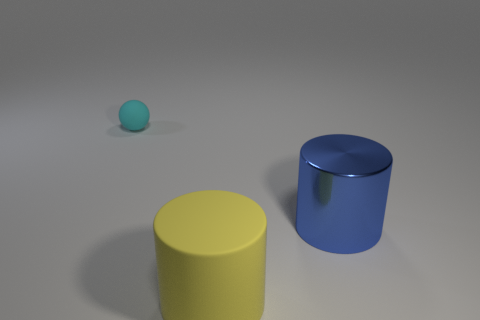Add 2 rubber things. How many objects exist? 5 Subtract 1 cylinders. How many cylinders are left? 1 Subtract all spheres. How many objects are left? 2 Add 2 cyan matte things. How many cyan matte things are left? 3 Add 3 big blue things. How many big blue things exist? 4 Subtract 0 yellow balls. How many objects are left? 3 Subtract all brown cylinders. Subtract all red balls. How many cylinders are left? 2 Subtract all yellow cubes. How many blue cylinders are left? 1 Subtract all large yellow cylinders. Subtract all large blue metal cylinders. How many objects are left? 1 